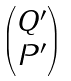<formula> <loc_0><loc_0><loc_500><loc_500>\begin{pmatrix} Q ^ { \prime } \\ P ^ { \prime } \end{pmatrix}</formula> 